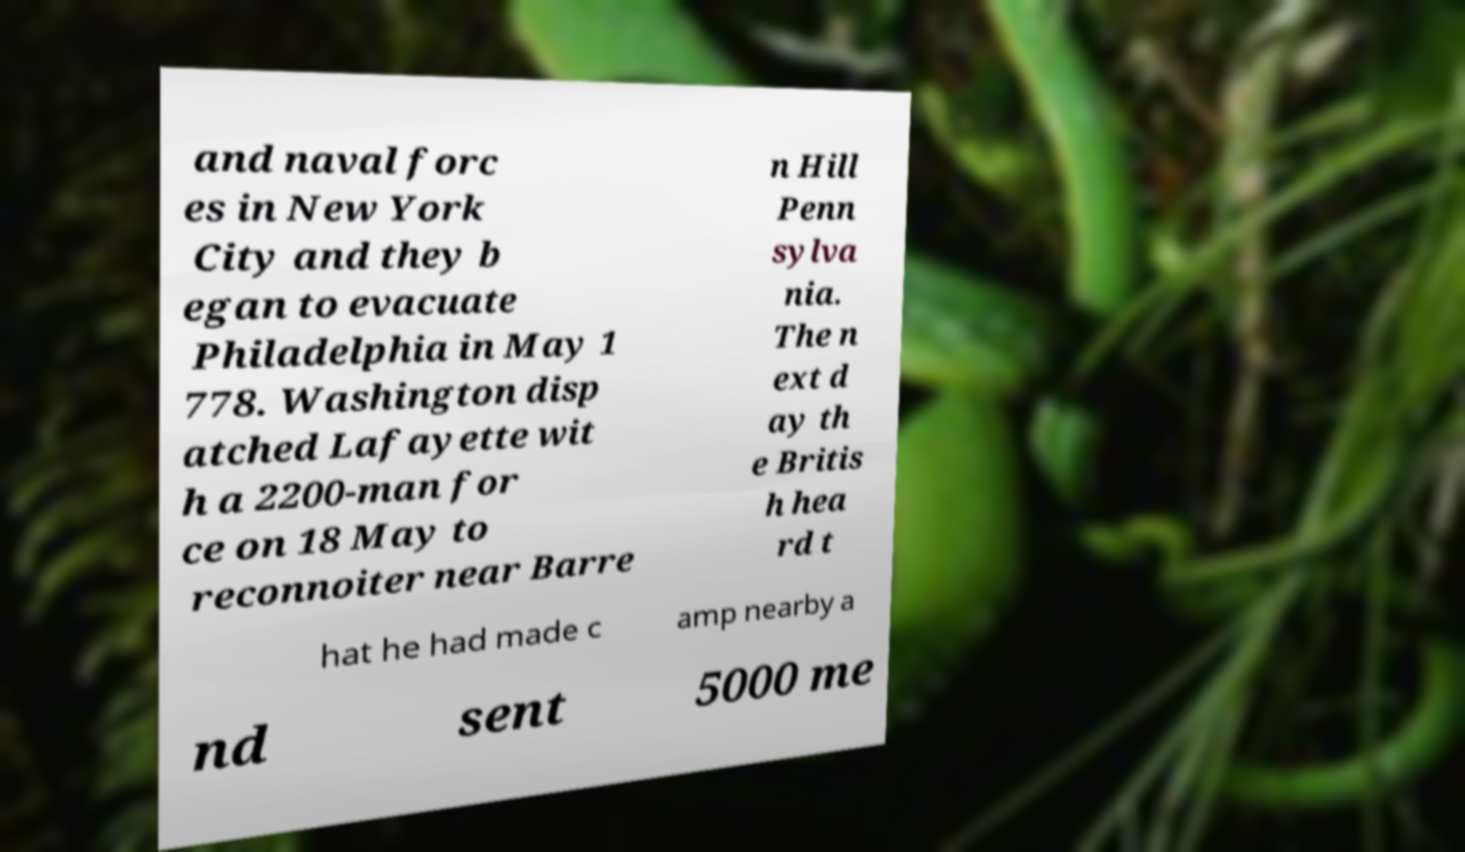Could you assist in decoding the text presented in this image and type it out clearly? and naval forc es in New York City and they b egan to evacuate Philadelphia in May 1 778. Washington disp atched Lafayette wit h a 2200-man for ce on 18 May to reconnoiter near Barre n Hill Penn sylva nia. The n ext d ay th e Britis h hea rd t hat he had made c amp nearby a nd sent 5000 me 